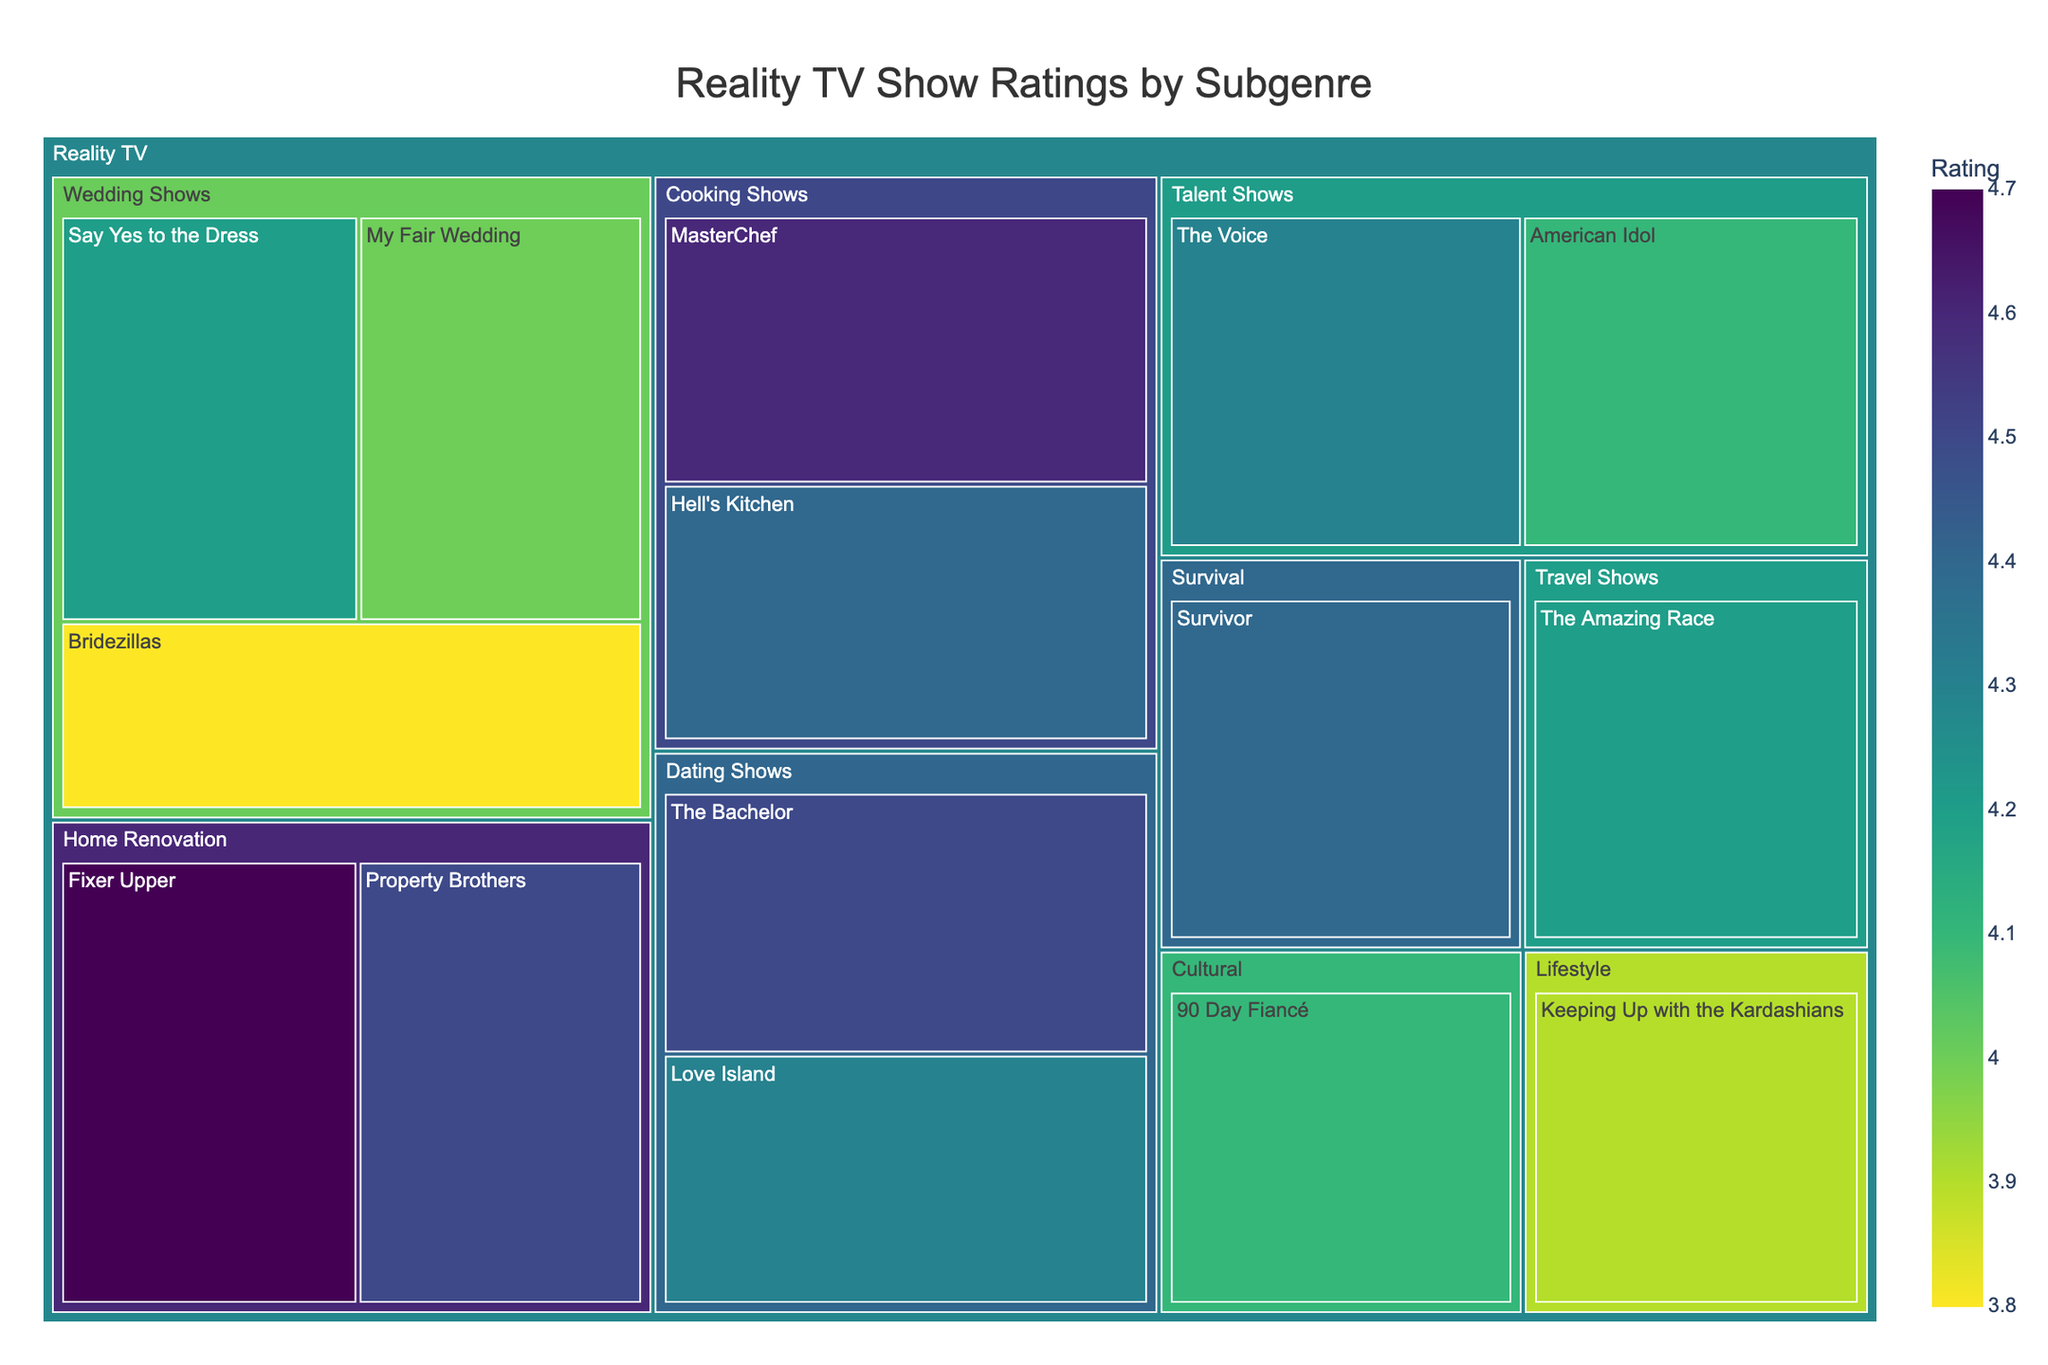What is the title of the treemap? The title is usually displayed at the top of the treemap to provide a summarizing description of the data contained within it. You can directly read it from the plot.
Answer: Reality TV Show Ratings by Subgenre How many wedding shows are listed in the treemap? To find the number of wedding shows, look for the section labeled "Wedding Shows" under the category "Reality TV" and count the number of shows listed.
Answer: 3 Which subgenre has the highest-rated show? Identify the highest rating value in the plot, then trace back to see under which subgenre this show is categorized.
Answer: Home Renovation What is the average rating of the Wedding Shows? To calculate the average rating of Wedding Shows, sum up their ratings and divide by the total number of wedding shows. The shows and their ratings are: Say Yes to the Dress (4.2), Bridezillas (3.8), My Fair Wedding (4.0). (4.2 + 3.8 + 4.0)/3 = 4
Answer: 4.0 Which show appeals to "Women 18-34" the most, and what is its rating? Locate the demographic appeal "Women 18-34" among the shows and observe their ratings. The show with the highest rating that appeals to this demographic is identified.
Answer: The Bachelor, 4.5 Are there more shows appealing to "Women 18-34" or "Adults 25-54"? Count the number of shows appealing to "Women 18-34" and "Adults 25-54," then compare the counts to determine which has more. "Women 18-34" includes: Say Yes to the Dress, The Bachelor, Keeping Up with the Kardashians (3); "Adults 25-54" includes: MasterChef, Fixer Upper, The Voice, Survivor (4).
Answer: Adults 25-54 Which subgenre has the most diverse demographic appeal? Determine which subgenre has the broadest range of demographic categories represented.
Answer: Reality TV Which show within the "Talent Shows" subgenre has a higher rating, "American Idol" or "The Voice"? Compare the ratings of the shows listed under the subgenre "Talent Shows.” American Idol has a rating of 4.1, while The Voice has a rating of 4.3.
Answer: The Voice What is the demographic appeal of "Fixer Upper"? The demographic appeal is typically listed as hover data or directly in the plot for each show. Locate "Fixer Upper" and read the demographic information.
Answer: Adults 25-54 What is the combined rating of all Cooking Shows? To find the combined rating, sum the ratings of all shows categorized under "Cooking Shows." The shows and their ratings are: MasterChef (4.6) and Hell's Kitchen (4.4). 4.6 + 4.4 = 9.0
Answer: 9.0 